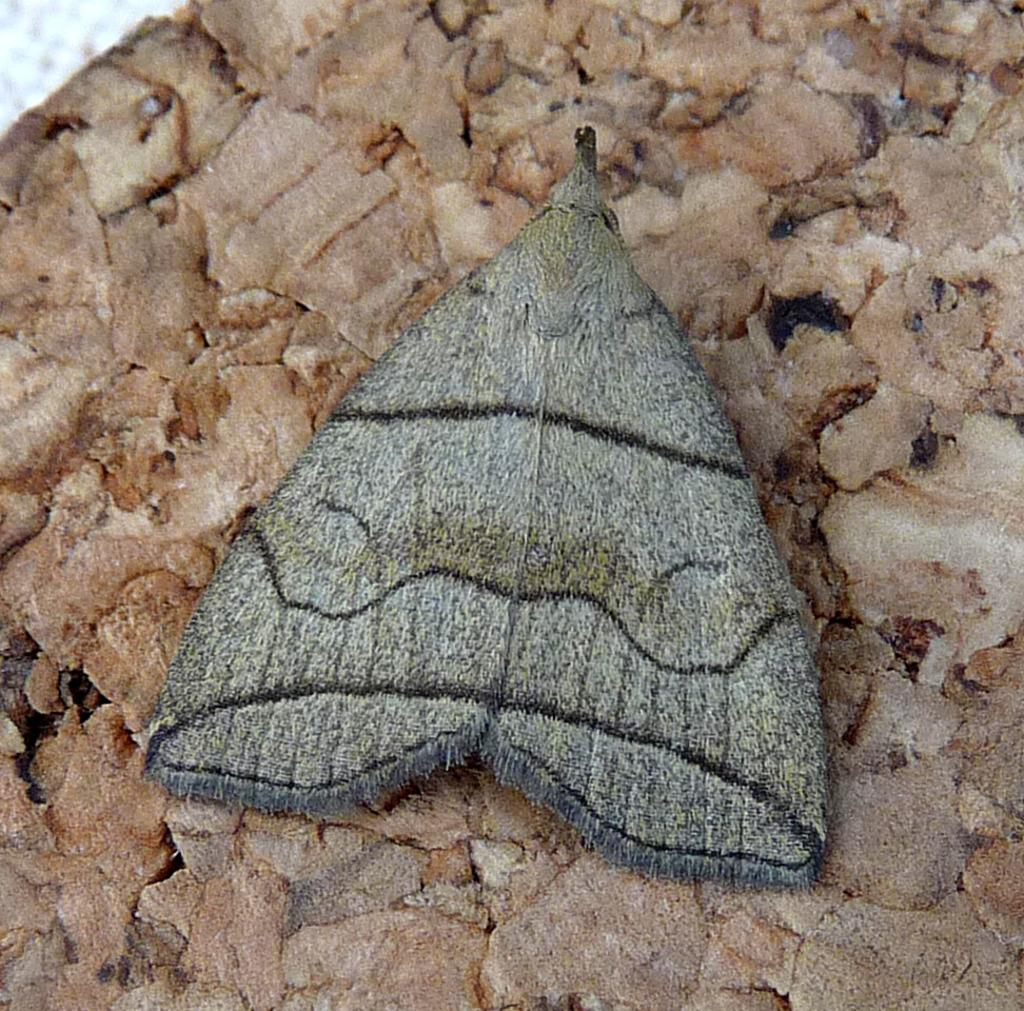What is the main subject of the image? There is a butterfly in the image. Where is the butterfly located? The butterfly is on a stone. What type of creature is pointing a gun at the butterfly in the image? There is no creature or gun present in the image; it only features a butterfly on a stone. 